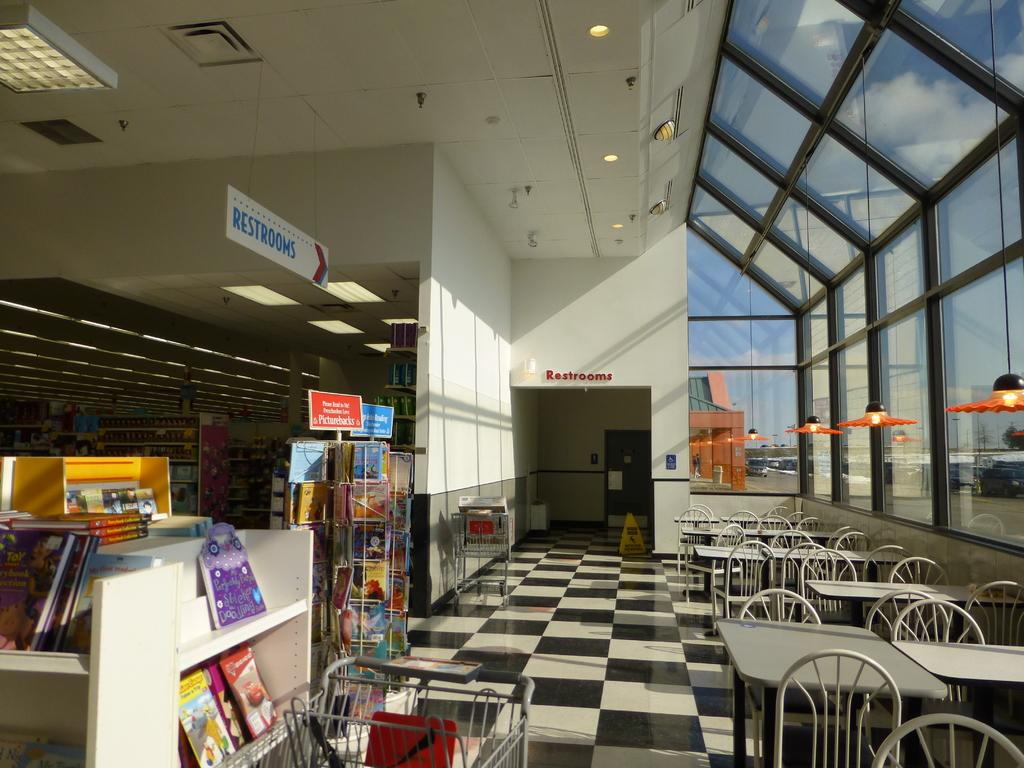What type of furniture can be seen in the corner of the image? There are tables and chairs in the corner of the image. What can be found on the wall in the image? There is a bookshelf in the image. What type of location does the image appear to depict? The setting appears to be a market. What information is provided by the banner in the image? The banner in the image reads "Rest Rooms". Are there any cherries being sold at the market in the image? There is no information about cherries being sold in the image; it only shows tables, chairs, a bookshelf, and a banner for restrooms. Can you see a clam being prepared at a food stall in the image? There is no food stall or clam visible in the image. 